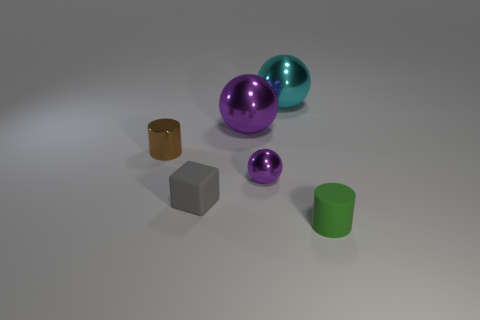There is a large ball to the right of the large purple thing; does it have the same color as the metal object that is in front of the brown cylinder?
Offer a very short reply. No. The small metal object that is in front of the cylinder that is behind the green cylinder is what shape?
Keep it short and to the point. Sphere. Is there another metallic sphere of the same size as the cyan metallic sphere?
Your answer should be very brief. Yes. What number of other objects have the same shape as the tiny purple metal object?
Your answer should be compact. 2. Is the number of small objects to the left of the large purple ball the same as the number of big purple spheres that are right of the large cyan object?
Offer a very short reply. No. Are any matte blocks visible?
Give a very brief answer. Yes. There is a rubber thing that is on the right side of the large sphere that is behind the large sphere that is in front of the large cyan ball; what is its size?
Your answer should be very brief. Small. The purple object that is the same size as the green cylinder is what shape?
Make the answer very short. Sphere. Is there any other thing that is the same material as the large purple sphere?
Provide a short and direct response. Yes. What number of things are objects on the left side of the tiny green rubber thing or small things?
Provide a short and direct response. 6. 